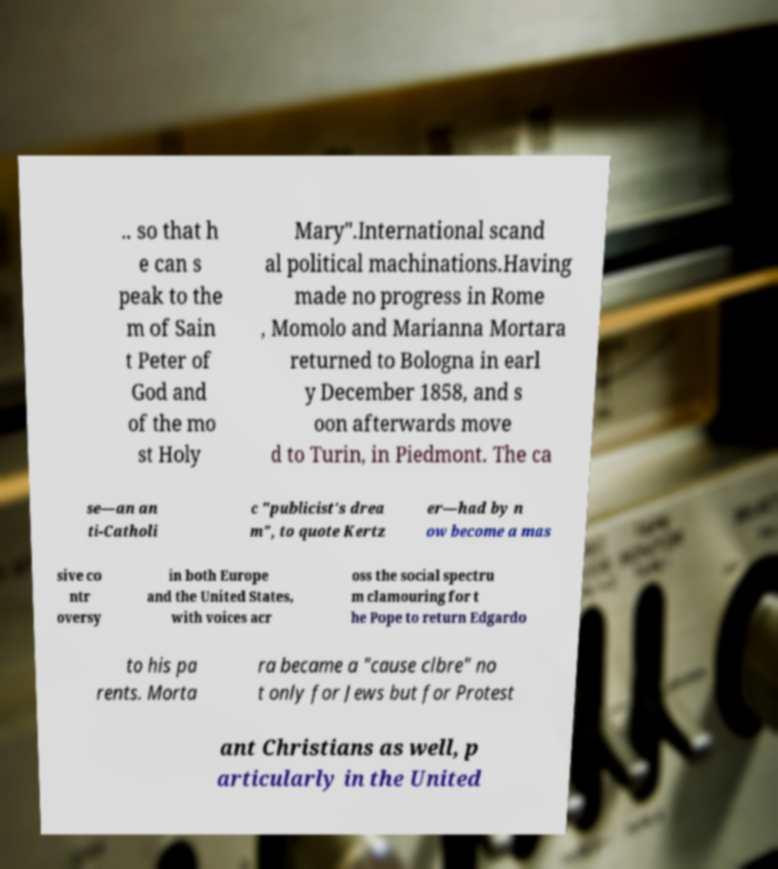Could you assist in decoding the text presented in this image and type it out clearly? .. so that h e can s peak to the m of Sain t Peter of God and of the mo st Holy Mary".International scand al political machinations.Having made no progress in Rome , Momolo and Marianna Mortara returned to Bologna in earl y December 1858, and s oon afterwards move d to Turin, in Piedmont. The ca se—an an ti-Catholi c "publicist's drea m", to quote Kertz er—had by n ow become a mas sive co ntr oversy in both Europe and the United States, with voices acr oss the social spectru m clamouring for t he Pope to return Edgardo to his pa rents. Morta ra became a "cause clbre" no t only for Jews but for Protest ant Christians as well, p articularly in the United 